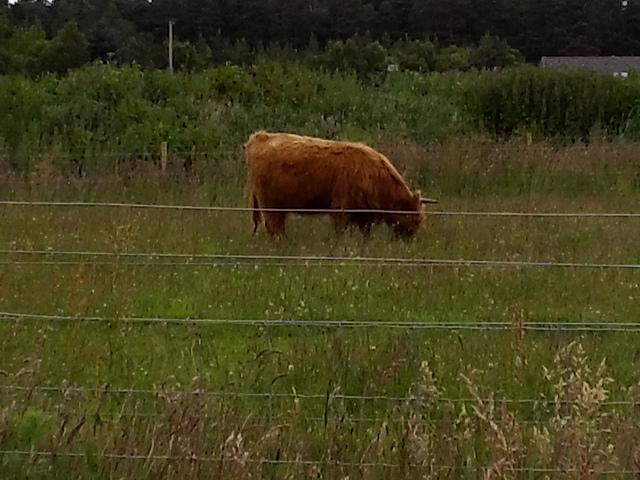How many animals are there?
Give a very brief answer. 1. How many person in the image is wearing black color t-shirt?
Give a very brief answer. 0. 